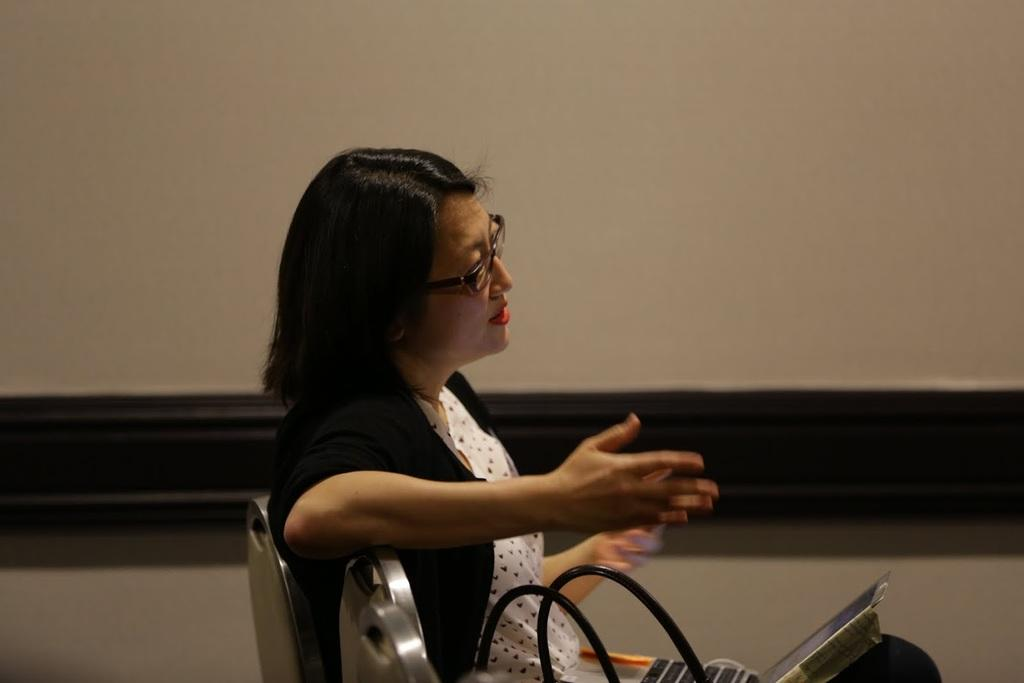What is the woman in the image doing? The woman is sitting on a chair in the image. What electronic device can be seen in the image? There is a laptop in the image. What is attached to the wall in the image? There is a whiteboard attached to the wall in the image. Can you see the moon in the image? No, the moon is not present in the image. What is the woman pointing at in the image? There is no indication in the image that the woman is pointing at anything. 